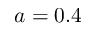Convert formula to latex. <formula><loc_0><loc_0><loc_500><loc_500>a = 0 . 4</formula> 